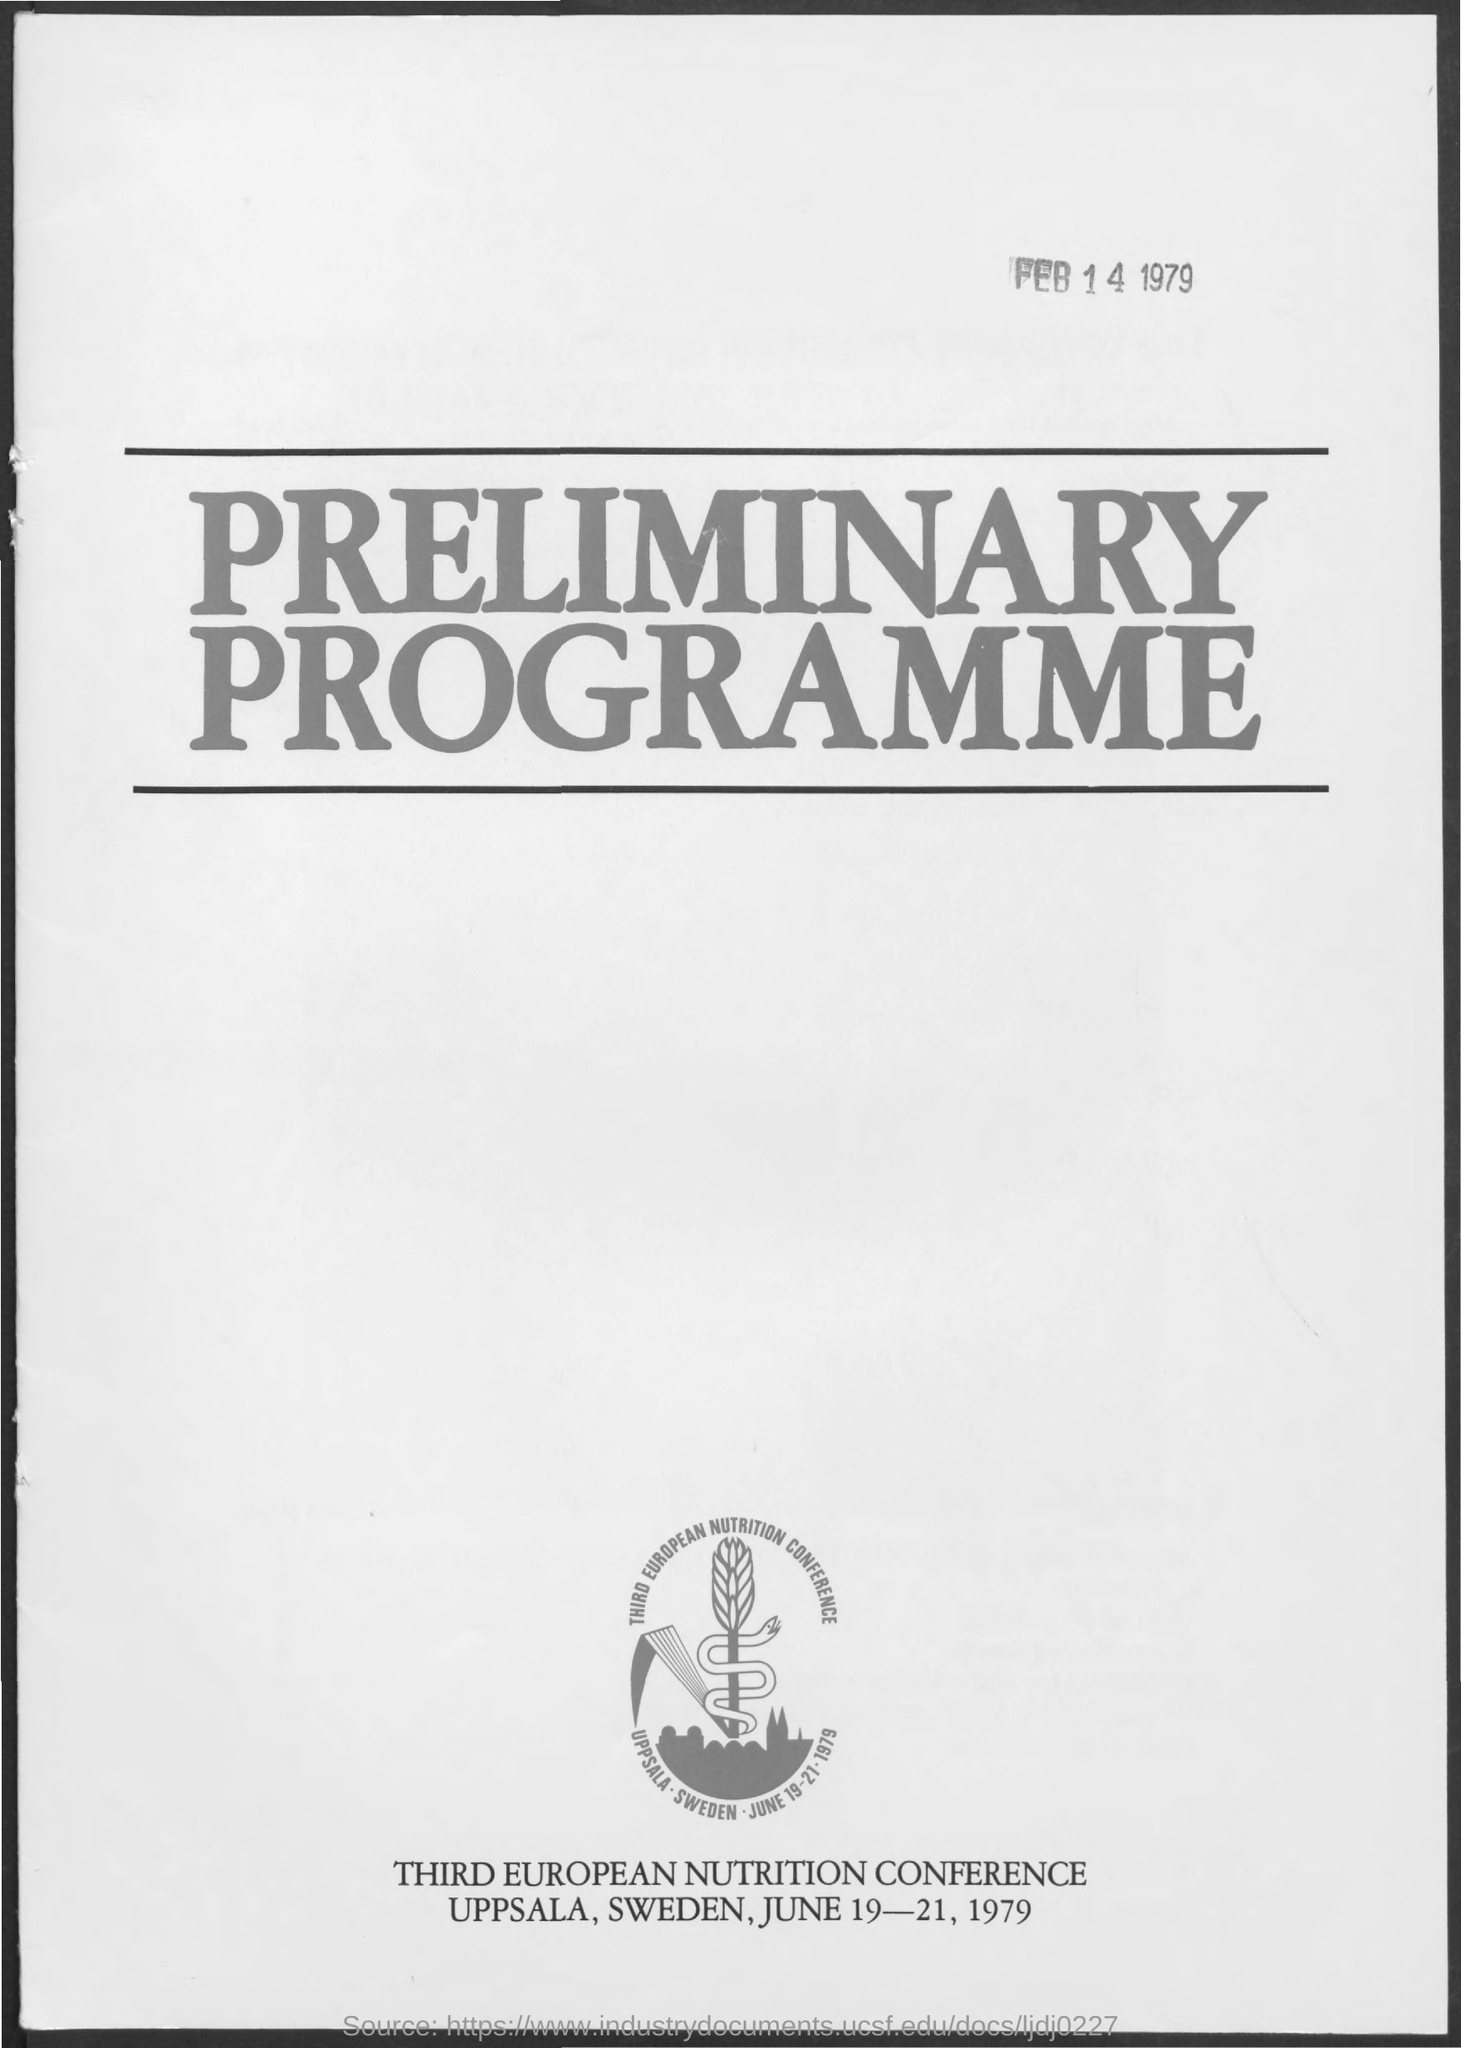Highlight a few significant elements in this photo. The title of the document is 'Preliminary Programme.' The Third European Nutrition Conference will take place in Uppsala, Sweden. The Third European Nutrition Conference is scheduled to take place on June 19-21, 1979. 